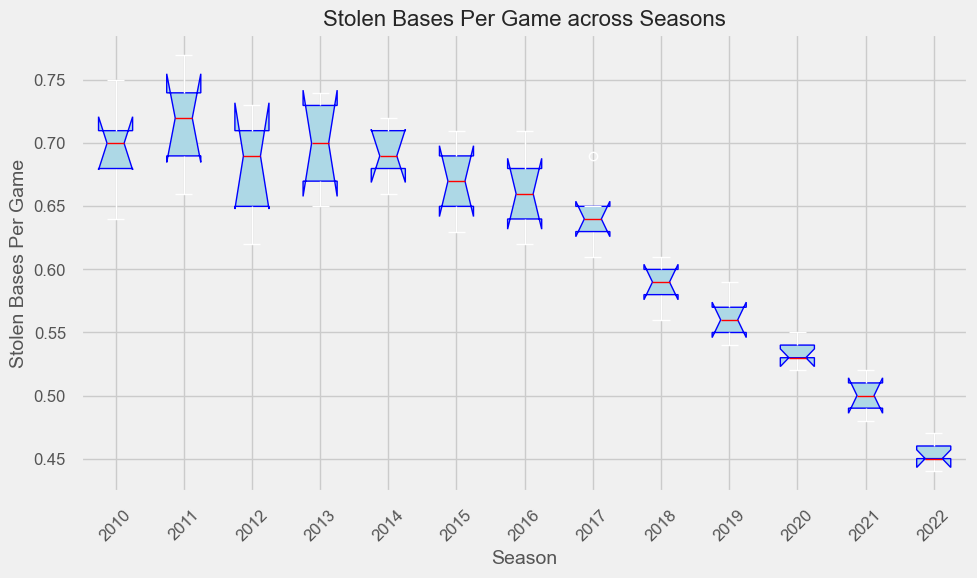What's the median value of Stolen Bases Per Game in 2012? Locate the median line within the box of the 2012 season. The median is indicated by the red line within the box plot.
Answer: 0.69 Which season has the highest median value of Stolen Bases Per Game? Compare the median lines (red) across all box plots for each season. The highest median value can be observed visually.
Answer: 2011 Is the interquartile range (IQR) larger in 2014 or 2017? The IQR is the range between the 1st quartile (bottom of the box) and the 3rd quartile (top of the box). Compare the heights of the boxes for 2014 and 2017.
Answer: 2014 Which season shows the lowest median value of Stolen Bases Per Game? Identify the lowest median line (red) among all seasons.
Answer: 2022 How does the spread of 'Stolen Bases Per Game' in 2016 compare to 2018? The spread can be understood by looking at the range from the bottom whisker to the top whisker. Compare these ranges between 2016 and 2018.
Answer: 2016 has a larger spread Is the first quartile value higher in 2015 or 2020? The first quartile is the bottom of the box. Compare the bottom of the boxes for 2015 and 2020.
Answer: 2015 Which season has the narrowest box, indicating the least variation in Stolen Bases per Game? The narrowest box has the smallest height between the 1st and 3rd quartiles. Compare the heights of the boxes across all seasons.
Answer: 2021 Between 2010 and 2019, which season had the highest maximum value of Stolen Bases Per Game? The highest maximum value is indicated by the top whisker. Compare the top whiskers for the seasons between 2010 and 2019.
Answer: 2011 